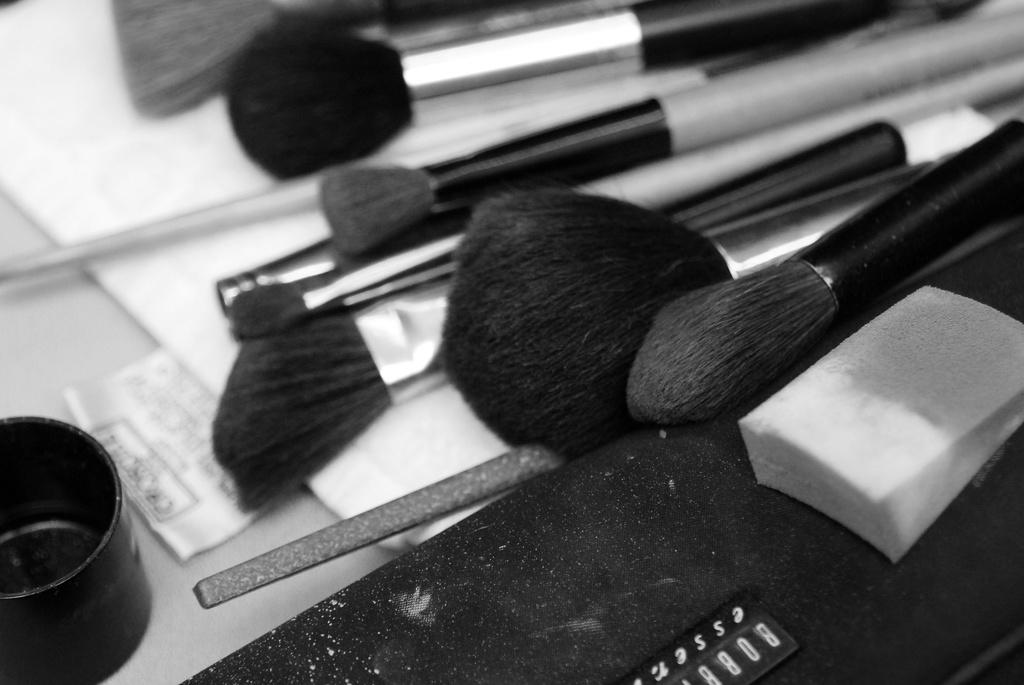What is the color scheme of the image? The image is black and white. What objects are present in the image? There are makeup brushes in the image. Where are the makeup brushes located? The makeup brushes are placed on a table. Can you see any beans on the slope in the image? There is no slope or beans present in the image; it features black and white makeup brushes placed on a table. 